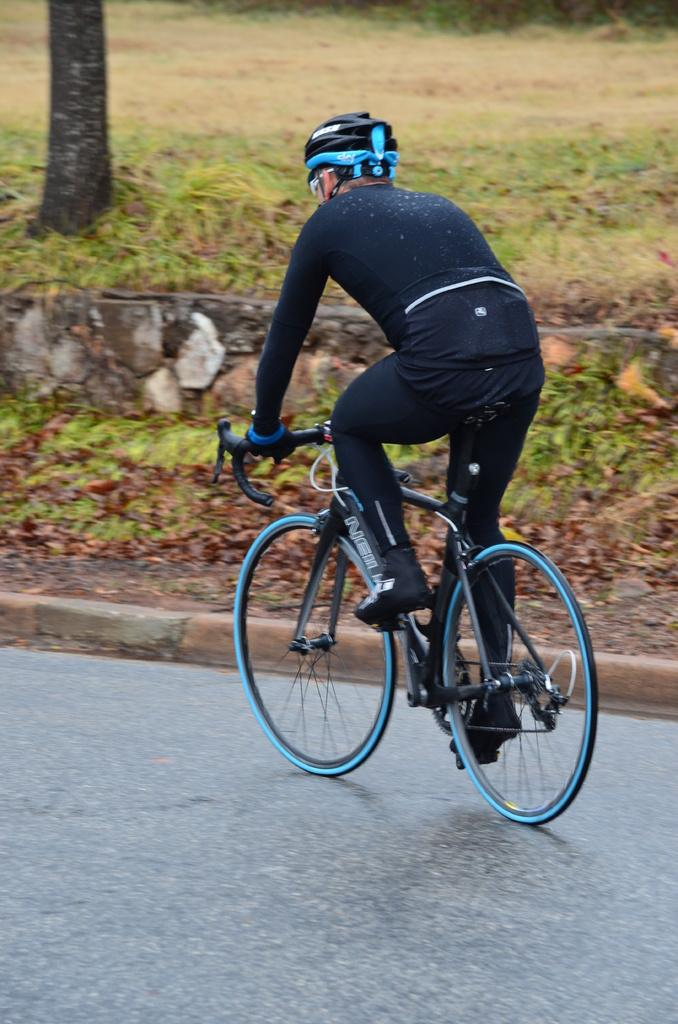What is the person in the image doing? The person is riding a bicycle. Where is the bicycle located? The bicycle is on the road. What is in front of the person while riding the bicycle? There is a tree trunk, grass, and a wall in front of the person. What type of sound can be heard coming from the swing in the image? There is no swing present in the image, so no sound can be heard from it. 